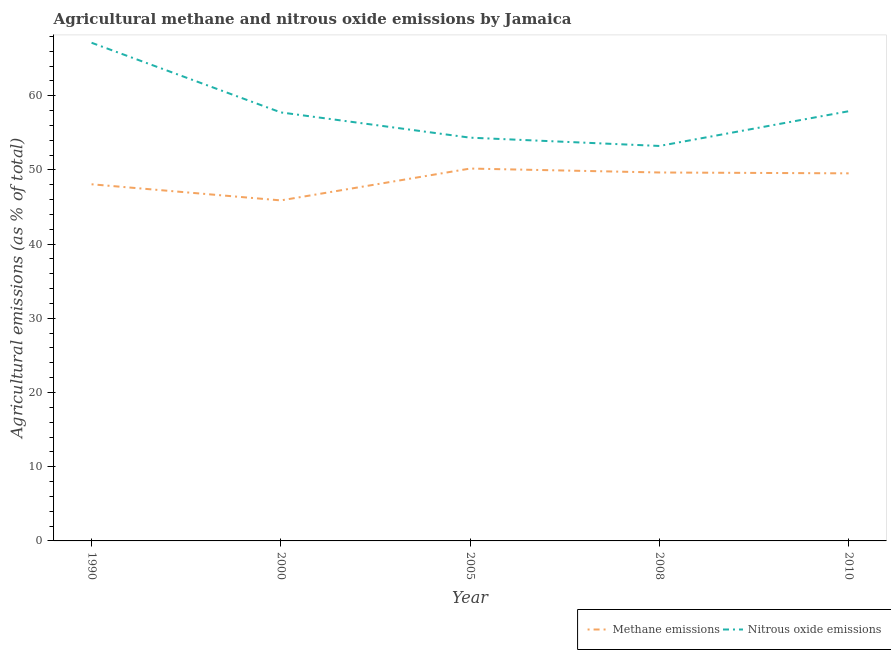Does the line corresponding to amount of nitrous oxide emissions intersect with the line corresponding to amount of methane emissions?
Provide a succinct answer. No. What is the amount of nitrous oxide emissions in 2000?
Offer a terse response. 57.75. Across all years, what is the maximum amount of methane emissions?
Keep it short and to the point. 50.18. Across all years, what is the minimum amount of methane emissions?
Make the answer very short. 45.89. In which year was the amount of nitrous oxide emissions minimum?
Offer a terse response. 2008. What is the total amount of nitrous oxide emissions in the graph?
Keep it short and to the point. 290.35. What is the difference between the amount of methane emissions in 1990 and that in 2000?
Your answer should be compact. 2.17. What is the difference between the amount of nitrous oxide emissions in 2005 and the amount of methane emissions in 2000?
Keep it short and to the point. 8.45. What is the average amount of methane emissions per year?
Make the answer very short. 48.66. In the year 2000, what is the difference between the amount of nitrous oxide emissions and amount of methane emissions?
Provide a short and direct response. 11.86. What is the ratio of the amount of methane emissions in 1990 to that in 2008?
Provide a short and direct response. 0.97. What is the difference between the highest and the second highest amount of methane emissions?
Your response must be concise. 0.53. What is the difference between the highest and the lowest amount of nitrous oxide emissions?
Keep it short and to the point. 13.91. In how many years, is the amount of nitrous oxide emissions greater than the average amount of nitrous oxide emissions taken over all years?
Ensure brevity in your answer.  1. Is the sum of the amount of methane emissions in 2005 and 2008 greater than the maximum amount of nitrous oxide emissions across all years?
Give a very brief answer. Yes. What is the difference between two consecutive major ticks on the Y-axis?
Your response must be concise. 10. Are the values on the major ticks of Y-axis written in scientific E-notation?
Keep it short and to the point. No. Does the graph contain grids?
Keep it short and to the point. No. What is the title of the graph?
Provide a succinct answer. Agricultural methane and nitrous oxide emissions by Jamaica. Does "Boys" appear as one of the legend labels in the graph?
Offer a terse response. No. What is the label or title of the Y-axis?
Offer a very short reply. Agricultural emissions (as % of total). What is the Agricultural emissions (as % of total) of Methane emissions in 1990?
Ensure brevity in your answer.  48.06. What is the Agricultural emissions (as % of total) in Nitrous oxide emissions in 1990?
Provide a succinct answer. 67.13. What is the Agricultural emissions (as % of total) of Methane emissions in 2000?
Your answer should be compact. 45.89. What is the Agricultural emissions (as % of total) in Nitrous oxide emissions in 2000?
Your answer should be compact. 57.75. What is the Agricultural emissions (as % of total) in Methane emissions in 2005?
Ensure brevity in your answer.  50.18. What is the Agricultural emissions (as % of total) in Nitrous oxide emissions in 2005?
Give a very brief answer. 54.34. What is the Agricultural emissions (as % of total) of Methane emissions in 2008?
Give a very brief answer. 49.65. What is the Agricultural emissions (as % of total) in Nitrous oxide emissions in 2008?
Provide a succinct answer. 53.23. What is the Agricultural emissions (as % of total) in Methane emissions in 2010?
Your answer should be compact. 49.54. What is the Agricultural emissions (as % of total) of Nitrous oxide emissions in 2010?
Your answer should be compact. 57.9. Across all years, what is the maximum Agricultural emissions (as % of total) in Methane emissions?
Offer a very short reply. 50.18. Across all years, what is the maximum Agricultural emissions (as % of total) of Nitrous oxide emissions?
Provide a succinct answer. 67.13. Across all years, what is the minimum Agricultural emissions (as % of total) in Methane emissions?
Ensure brevity in your answer.  45.89. Across all years, what is the minimum Agricultural emissions (as % of total) of Nitrous oxide emissions?
Your answer should be very brief. 53.23. What is the total Agricultural emissions (as % of total) in Methane emissions in the graph?
Make the answer very short. 243.32. What is the total Agricultural emissions (as % of total) of Nitrous oxide emissions in the graph?
Your answer should be compact. 290.35. What is the difference between the Agricultural emissions (as % of total) in Methane emissions in 1990 and that in 2000?
Offer a very short reply. 2.17. What is the difference between the Agricultural emissions (as % of total) of Nitrous oxide emissions in 1990 and that in 2000?
Your answer should be compact. 9.39. What is the difference between the Agricultural emissions (as % of total) of Methane emissions in 1990 and that in 2005?
Offer a very short reply. -2.12. What is the difference between the Agricultural emissions (as % of total) of Nitrous oxide emissions in 1990 and that in 2005?
Provide a succinct answer. 12.79. What is the difference between the Agricultural emissions (as % of total) of Methane emissions in 1990 and that in 2008?
Ensure brevity in your answer.  -1.59. What is the difference between the Agricultural emissions (as % of total) of Nitrous oxide emissions in 1990 and that in 2008?
Your answer should be very brief. 13.91. What is the difference between the Agricultural emissions (as % of total) in Methane emissions in 1990 and that in 2010?
Your answer should be very brief. -1.47. What is the difference between the Agricultural emissions (as % of total) in Nitrous oxide emissions in 1990 and that in 2010?
Ensure brevity in your answer.  9.23. What is the difference between the Agricultural emissions (as % of total) of Methane emissions in 2000 and that in 2005?
Offer a very short reply. -4.29. What is the difference between the Agricultural emissions (as % of total) in Nitrous oxide emissions in 2000 and that in 2005?
Your answer should be compact. 3.4. What is the difference between the Agricultural emissions (as % of total) in Methane emissions in 2000 and that in 2008?
Offer a very short reply. -3.76. What is the difference between the Agricultural emissions (as % of total) in Nitrous oxide emissions in 2000 and that in 2008?
Ensure brevity in your answer.  4.52. What is the difference between the Agricultural emissions (as % of total) of Methane emissions in 2000 and that in 2010?
Keep it short and to the point. -3.65. What is the difference between the Agricultural emissions (as % of total) of Nitrous oxide emissions in 2000 and that in 2010?
Provide a short and direct response. -0.16. What is the difference between the Agricultural emissions (as % of total) of Methane emissions in 2005 and that in 2008?
Your answer should be very brief. 0.53. What is the difference between the Agricultural emissions (as % of total) of Nitrous oxide emissions in 2005 and that in 2008?
Offer a very short reply. 1.12. What is the difference between the Agricultural emissions (as % of total) of Methane emissions in 2005 and that in 2010?
Your answer should be compact. 0.64. What is the difference between the Agricultural emissions (as % of total) of Nitrous oxide emissions in 2005 and that in 2010?
Ensure brevity in your answer.  -3.56. What is the difference between the Agricultural emissions (as % of total) of Methane emissions in 2008 and that in 2010?
Make the answer very short. 0.12. What is the difference between the Agricultural emissions (as % of total) in Nitrous oxide emissions in 2008 and that in 2010?
Your response must be concise. -4.68. What is the difference between the Agricultural emissions (as % of total) in Methane emissions in 1990 and the Agricultural emissions (as % of total) in Nitrous oxide emissions in 2000?
Give a very brief answer. -9.68. What is the difference between the Agricultural emissions (as % of total) in Methane emissions in 1990 and the Agricultural emissions (as % of total) in Nitrous oxide emissions in 2005?
Your response must be concise. -6.28. What is the difference between the Agricultural emissions (as % of total) in Methane emissions in 1990 and the Agricultural emissions (as % of total) in Nitrous oxide emissions in 2008?
Provide a succinct answer. -5.16. What is the difference between the Agricultural emissions (as % of total) of Methane emissions in 1990 and the Agricultural emissions (as % of total) of Nitrous oxide emissions in 2010?
Your answer should be very brief. -9.84. What is the difference between the Agricultural emissions (as % of total) of Methane emissions in 2000 and the Agricultural emissions (as % of total) of Nitrous oxide emissions in 2005?
Keep it short and to the point. -8.45. What is the difference between the Agricultural emissions (as % of total) of Methane emissions in 2000 and the Agricultural emissions (as % of total) of Nitrous oxide emissions in 2008?
Give a very brief answer. -7.34. What is the difference between the Agricultural emissions (as % of total) in Methane emissions in 2000 and the Agricultural emissions (as % of total) in Nitrous oxide emissions in 2010?
Provide a short and direct response. -12.02. What is the difference between the Agricultural emissions (as % of total) of Methane emissions in 2005 and the Agricultural emissions (as % of total) of Nitrous oxide emissions in 2008?
Provide a short and direct response. -3.05. What is the difference between the Agricultural emissions (as % of total) of Methane emissions in 2005 and the Agricultural emissions (as % of total) of Nitrous oxide emissions in 2010?
Make the answer very short. -7.72. What is the difference between the Agricultural emissions (as % of total) of Methane emissions in 2008 and the Agricultural emissions (as % of total) of Nitrous oxide emissions in 2010?
Provide a succinct answer. -8.25. What is the average Agricultural emissions (as % of total) of Methane emissions per year?
Your answer should be compact. 48.66. What is the average Agricultural emissions (as % of total) of Nitrous oxide emissions per year?
Give a very brief answer. 58.07. In the year 1990, what is the difference between the Agricultural emissions (as % of total) of Methane emissions and Agricultural emissions (as % of total) of Nitrous oxide emissions?
Provide a succinct answer. -19.07. In the year 2000, what is the difference between the Agricultural emissions (as % of total) in Methane emissions and Agricultural emissions (as % of total) in Nitrous oxide emissions?
Offer a terse response. -11.86. In the year 2005, what is the difference between the Agricultural emissions (as % of total) of Methane emissions and Agricultural emissions (as % of total) of Nitrous oxide emissions?
Offer a very short reply. -4.16. In the year 2008, what is the difference between the Agricultural emissions (as % of total) in Methane emissions and Agricultural emissions (as % of total) in Nitrous oxide emissions?
Offer a terse response. -3.57. In the year 2010, what is the difference between the Agricultural emissions (as % of total) in Methane emissions and Agricultural emissions (as % of total) in Nitrous oxide emissions?
Keep it short and to the point. -8.37. What is the ratio of the Agricultural emissions (as % of total) of Methane emissions in 1990 to that in 2000?
Your answer should be compact. 1.05. What is the ratio of the Agricultural emissions (as % of total) in Nitrous oxide emissions in 1990 to that in 2000?
Keep it short and to the point. 1.16. What is the ratio of the Agricultural emissions (as % of total) of Methane emissions in 1990 to that in 2005?
Give a very brief answer. 0.96. What is the ratio of the Agricultural emissions (as % of total) in Nitrous oxide emissions in 1990 to that in 2005?
Your response must be concise. 1.24. What is the ratio of the Agricultural emissions (as % of total) of Methane emissions in 1990 to that in 2008?
Offer a very short reply. 0.97. What is the ratio of the Agricultural emissions (as % of total) in Nitrous oxide emissions in 1990 to that in 2008?
Provide a succinct answer. 1.26. What is the ratio of the Agricultural emissions (as % of total) of Methane emissions in 1990 to that in 2010?
Keep it short and to the point. 0.97. What is the ratio of the Agricultural emissions (as % of total) of Nitrous oxide emissions in 1990 to that in 2010?
Give a very brief answer. 1.16. What is the ratio of the Agricultural emissions (as % of total) in Methane emissions in 2000 to that in 2005?
Offer a terse response. 0.91. What is the ratio of the Agricultural emissions (as % of total) of Nitrous oxide emissions in 2000 to that in 2005?
Ensure brevity in your answer.  1.06. What is the ratio of the Agricultural emissions (as % of total) of Methane emissions in 2000 to that in 2008?
Your response must be concise. 0.92. What is the ratio of the Agricultural emissions (as % of total) of Nitrous oxide emissions in 2000 to that in 2008?
Offer a terse response. 1.08. What is the ratio of the Agricultural emissions (as % of total) of Methane emissions in 2000 to that in 2010?
Give a very brief answer. 0.93. What is the ratio of the Agricultural emissions (as % of total) in Nitrous oxide emissions in 2000 to that in 2010?
Your response must be concise. 1. What is the ratio of the Agricultural emissions (as % of total) of Methane emissions in 2005 to that in 2008?
Offer a very short reply. 1.01. What is the ratio of the Agricultural emissions (as % of total) in Nitrous oxide emissions in 2005 to that in 2010?
Offer a terse response. 0.94. What is the ratio of the Agricultural emissions (as % of total) in Nitrous oxide emissions in 2008 to that in 2010?
Your response must be concise. 0.92. What is the difference between the highest and the second highest Agricultural emissions (as % of total) of Methane emissions?
Provide a succinct answer. 0.53. What is the difference between the highest and the second highest Agricultural emissions (as % of total) in Nitrous oxide emissions?
Ensure brevity in your answer.  9.23. What is the difference between the highest and the lowest Agricultural emissions (as % of total) of Methane emissions?
Make the answer very short. 4.29. What is the difference between the highest and the lowest Agricultural emissions (as % of total) of Nitrous oxide emissions?
Your answer should be very brief. 13.91. 